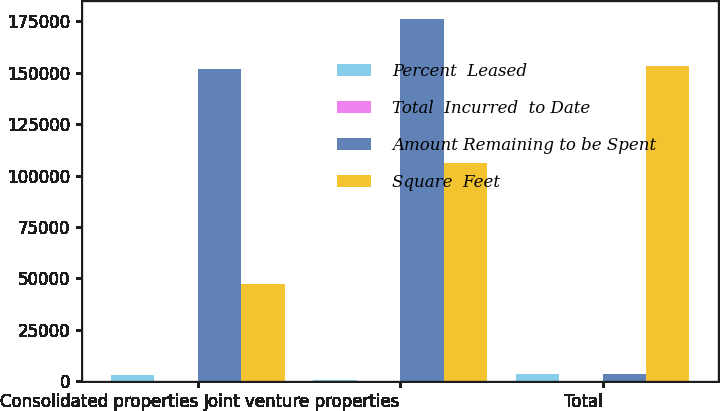Convert chart to OTSL. <chart><loc_0><loc_0><loc_500><loc_500><stacked_bar_chart><ecel><fcel>Consolidated properties<fcel>Joint venture properties<fcel>Total<nl><fcel>Percent  Leased<fcel>2895<fcel>866<fcel>3761<nl><fcel>Total  Incurred  to Date<fcel>90<fcel>96<fcel>92<nl><fcel>Amount Remaining to be Spent<fcel>151502<fcel>175985<fcel>3761<nl><fcel>Square  Feet<fcel>47181<fcel>106150<fcel>153331<nl></chart> 